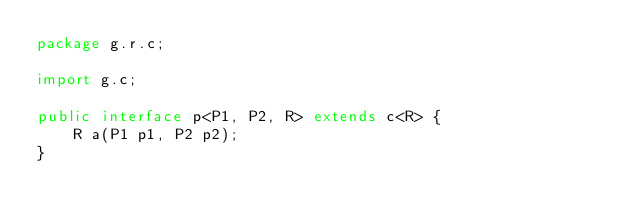Convert code to text. <code><loc_0><loc_0><loc_500><loc_500><_Java_>package g.r.c;

import g.c;

public interface p<P1, P2, R> extends c<R> {
    R a(P1 p1, P2 p2);
}
</code> 